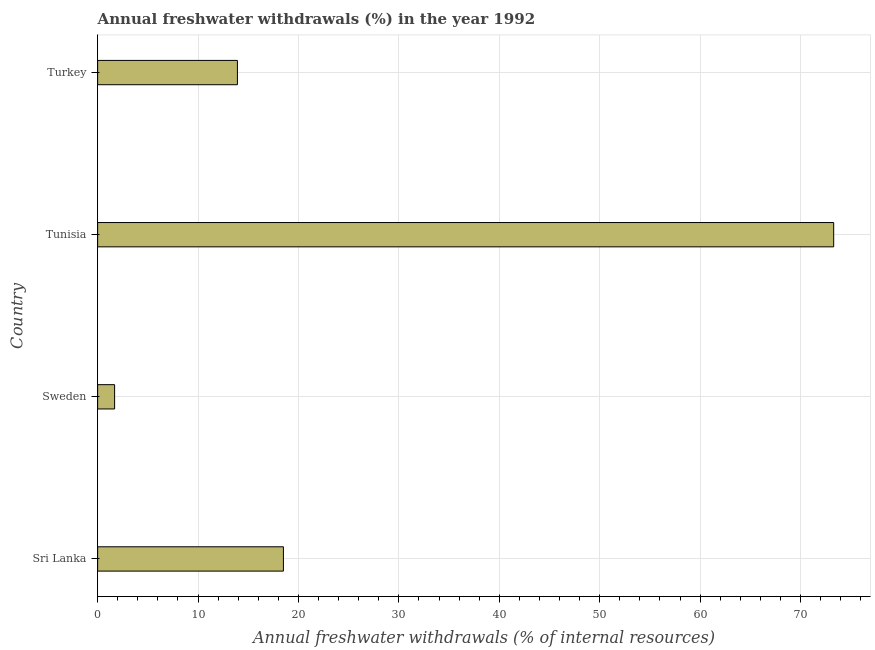Does the graph contain any zero values?
Your response must be concise. No. Does the graph contain grids?
Your response must be concise. Yes. What is the title of the graph?
Make the answer very short. Annual freshwater withdrawals (%) in the year 1992. What is the label or title of the X-axis?
Provide a short and direct response. Annual freshwater withdrawals (% of internal resources). What is the annual freshwater withdrawals in Turkey?
Give a very brief answer. 13.92. Across all countries, what is the maximum annual freshwater withdrawals?
Make the answer very short. 73.3. Across all countries, what is the minimum annual freshwater withdrawals?
Your answer should be compact. 1.69. In which country was the annual freshwater withdrawals maximum?
Give a very brief answer. Tunisia. What is the sum of the annual freshwater withdrawals?
Your answer should be very brief. 107.41. What is the difference between the annual freshwater withdrawals in Sri Lanka and Turkey?
Give a very brief answer. 4.58. What is the average annual freshwater withdrawals per country?
Your answer should be very brief. 26.85. What is the median annual freshwater withdrawals?
Provide a succinct answer. 16.21. What is the ratio of the annual freshwater withdrawals in Sweden to that in Turkey?
Provide a succinct answer. 0.12. Is the annual freshwater withdrawals in Sri Lanka less than that in Tunisia?
Offer a terse response. Yes. Is the difference between the annual freshwater withdrawals in Sri Lanka and Tunisia greater than the difference between any two countries?
Ensure brevity in your answer.  No. What is the difference between the highest and the second highest annual freshwater withdrawals?
Offer a terse response. 54.8. What is the difference between the highest and the lowest annual freshwater withdrawals?
Offer a very short reply. 71.61. How many bars are there?
Make the answer very short. 4. Are all the bars in the graph horizontal?
Provide a short and direct response. Yes. Are the values on the major ticks of X-axis written in scientific E-notation?
Offer a very short reply. No. What is the Annual freshwater withdrawals (% of internal resources) in Sri Lanka?
Your response must be concise. 18.5. What is the Annual freshwater withdrawals (% of internal resources) of Sweden?
Your response must be concise. 1.69. What is the Annual freshwater withdrawals (% of internal resources) of Tunisia?
Give a very brief answer. 73.3. What is the Annual freshwater withdrawals (% of internal resources) of Turkey?
Offer a very short reply. 13.92. What is the difference between the Annual freshwater withdrawals (% of internal resources) in Sri Lanka and Sweden?
Offer a terse response. 16.81. What is the difference between the Annual freshwater withdrawals (% of internal resources) in Sri Lanka and Tunisia?
Your response must be concise. -54.8. What is the difference between the Annual freshwater withdrawals (% of internal resources) in Sri Lanka and Turkey?
Provide a short and direct response. 4.58. What is the difference between the Annual freshwater withdrawals (% of internal resources) in Sweden and Tunisia?
Keep it short and to the point. -71.61. What is the difference between the Annual freshwater withdrawals (% of internal resources) in Sweden and Turkey?
Provide a succinct answer. -12.23. What is the difference between the Annual freshwater withdrawals (% of internal resources) in Tunisia and Turkey?
Ensure brevity in your answer.  59.38. What is the ratio of the Annual freshwater withdrawals (% of internal resources) in Sri Lanka to that in Sweden?
Your response must be concise. 10.95. What is the ratio of the Annual freshwater withdrawals (% of internal resources) in Sri Lanka to that in Tunisia?
Offer a terse response. 0.25. What is the ratio of the Annual freshwater withdrawals (% of internal resources) in Sri Lanka to that in Turkey?
Give a very brief answer. 1.33. What is the ratio of the Annual freshwater withdrawals (% of internal resources) in Sweden to that in Tunisia?
Provide a short and direct response. 0.02. What is the ratio of the Annual freshwater withdrawals (% of internal resources) in Sweden to that in Turkey?
Your answer should be compact. 0.12. What is the ratio of the Annual freshwater withdrawals (% of internal resources) in Tunisia to that in Turkey?
Offer a very short reply. 5.27. 